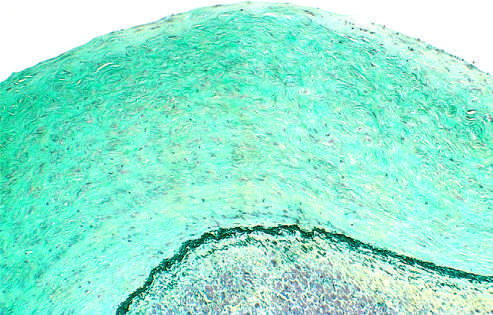do the white circles stain?
Answer the question using a single word or phrase. No 